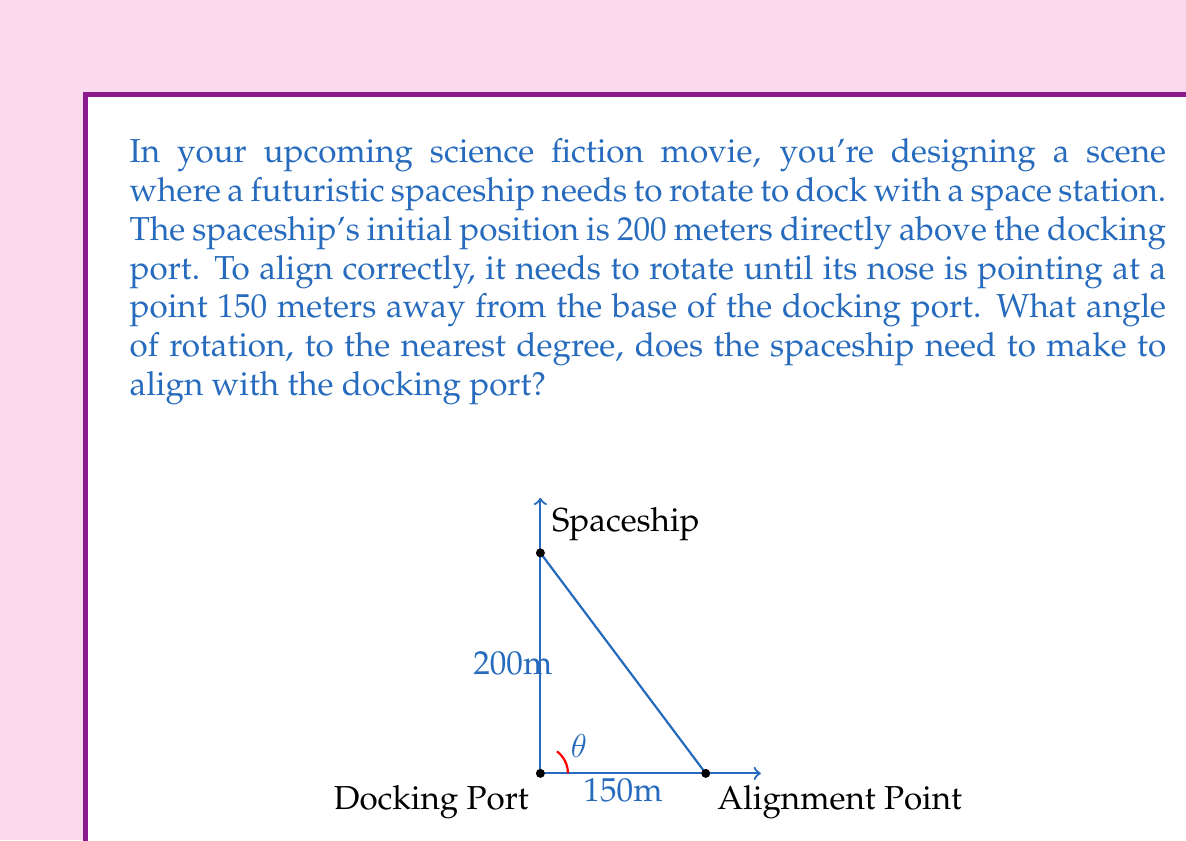Can you answer this question? Let's approach this step-by-step using trigonometry:

1) The scenario forms a right-angled triangle. We need to find the angle at the base (let's call it $\theta$).

2) We know:
   - The adjacent side (height) = 200 meters
   - The opposite side (distance from base) = 150 meters

3) To find the angle, we can use the tangent ratio:

   $$\tan(\theta) = \frac{\text{opposite}}{\text{adjacent}}$$

4) Plugging in our values:

   $$\tan(\theta) = \frac{150}{200}$$

5) To solve for $\theta$, we need to use the inverse tangent (arctan or $\tan^{-1}$):

   $$\theta = \tan^{-1}\left(\frac{150}{200}\right)$$

6) Using a calculator:

   $$\theta = \tan^{-1}(0.75) \approx 36.87\text{°}$$

7) Rounding to the nearest degree:

   $$\theta \approx 37\text{°}$$

Therefore, the spaceship needs to rotate approximately 37 degrees to align with the docking port.
Answer: 37° 